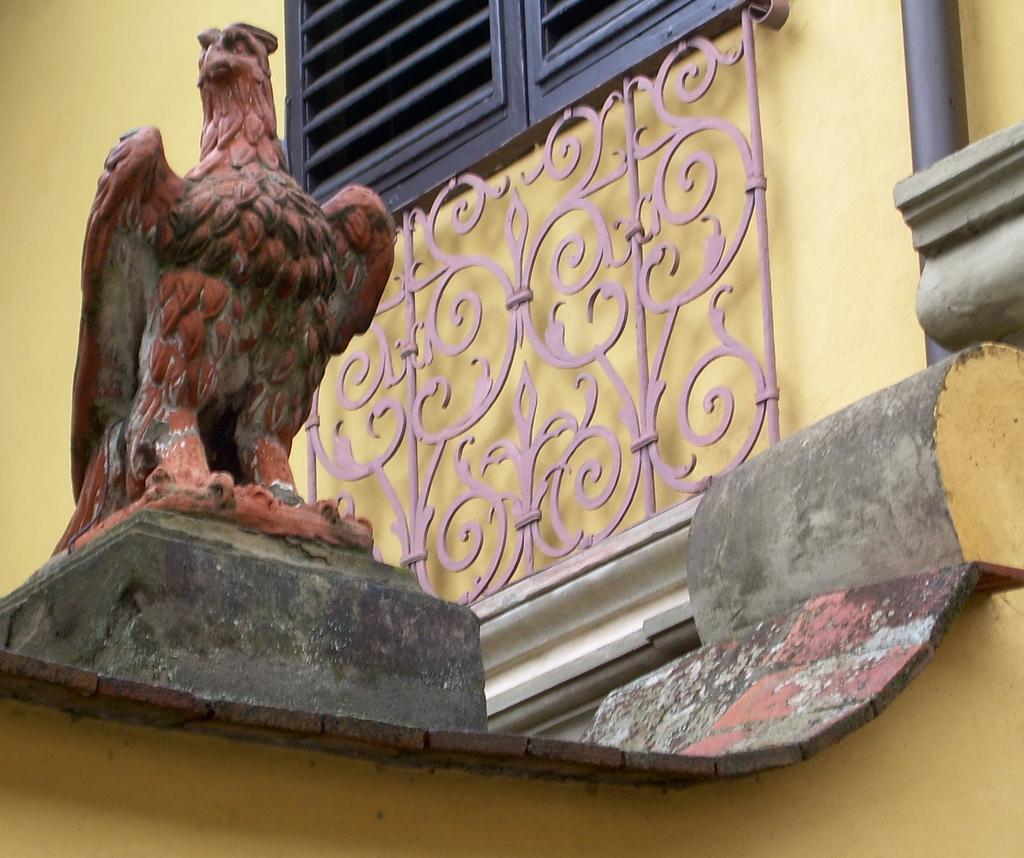What is the main subject of the image? There is a statue of an eagle in the image. What can be seen in the background of the image? There is a yellow color wall in the image. What feature does the wall have? The wall has a window. Are there any other objects attached to the wall? Yes, there are other objects attached to the wall. What type of rhythm can be heard coming from the eagle's statue in the image? There is no sound or rhythm associated with the eagle's statue in the image. 